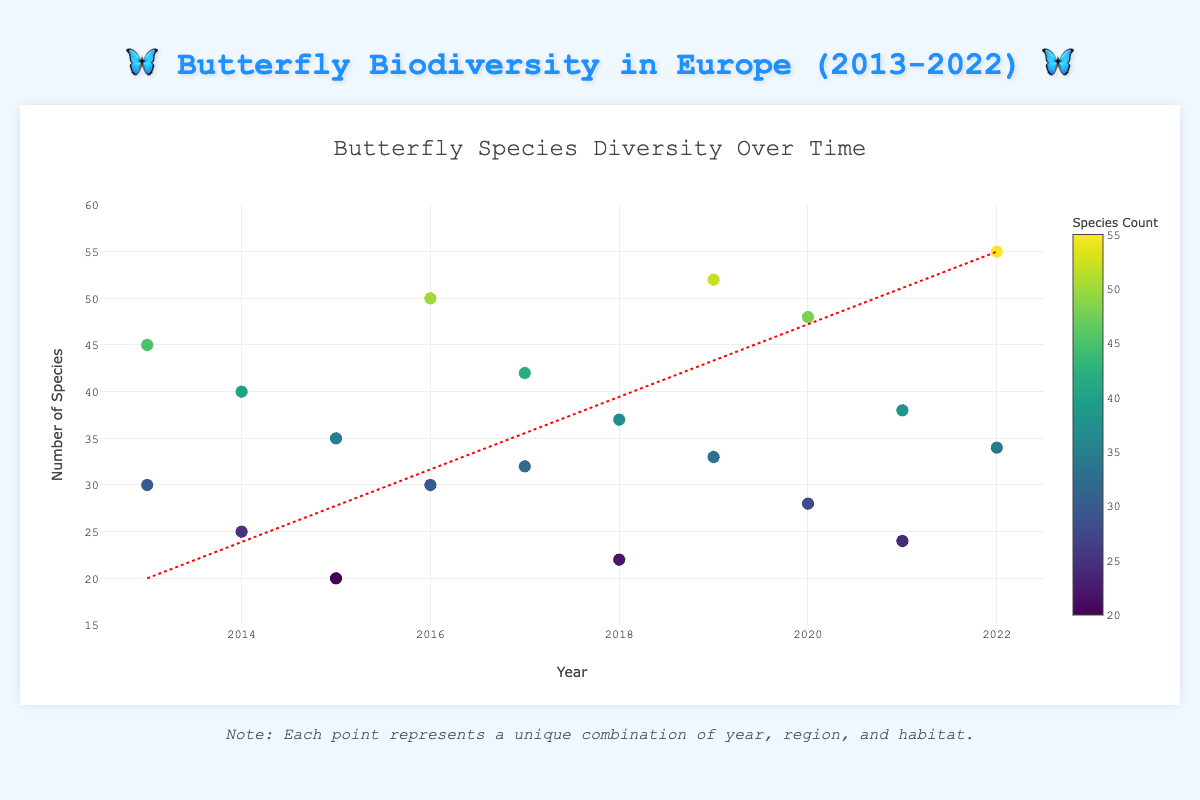what is the trend of butterfly species diversity over the years? The trend line in the scatter plot indicates a positive trend, showing that the number of butterfly species tends to increase over the years. This is visible from the line moving from the lower-left portion of the graph to the upper-right.
Answer: Increasing how many regions were studied in the dataset? By examining the number of unique regions in the scatter plot's hover information, one can count the mentions of different regions. The regions listed are: Mediterranean, Northern Europe, Western Europe, Eastern Europe, Southern Europe, and Central Europe.
Answer: 6 which habitat had the highest species count in a single year? By inspecting the hover information of the points and their corresponding species count, one can determine that the 'Coastal Areas' habitat in Southern Europe in 2022 had the highest species count of 55.
Answer: Coastal Areas what is the general range of butterfly species counted across all years? The y-axis shows the range of species count data points, extending from the lowest species count of 20 to the highest count of 55. These values are directly observable in the chart.
Answer: 20-55 which region had the greatest variation in species count over the years? By comparing the variation within each region's data points, one can see that the Mediterranean region had significant fluctuation, ranging from 30 in forests to 48 in grasslands. This can be confirmed by looking at the spread of data points associated with the Mediterranean region.
Answer: Mediterranean which years show data points for the 'Urban Gardens' habitat? By examining the scatter plot's hover information and noting the years associated with 'Urban Gardens' data points, one finds they appear in 2015, 2018, and 2021.
Answer: 2015, 2018, 2021 does Northern Europe show an increase or decrease in butterfly species in wetlands from 2014 to 2020? By comparing the hover information for wetlands in Northern Europe, species counts are 25 in 2014 and 28 in 2020, indicating a small increase.
Answer: Increase are there any outliers in the data? An outlier point is one that deviates markedly from other points. The 'Coastal Areas' habitat in Southern Europe in 2022, with a species count of 55, appears much higher than other points, suggesting it is an outlier.
Answer: Yes, Coastal Areas in Southern Europe in 2022 how does the species count in Central Europe in agrarian fields change between 2016 and 2022? Observing the points for Central Europe in agrarian fields, species counts are 30 in 2016 and 34 in 2022. This indicates an increase of 4 species over the period.
Answer: Increase which habitat types are represented in the Mediterranean region? By inspecting the hover information of data points associated with the Mediterranean region, the habitat types identified are 'Grassland' and 'Forest'.
Answer: Grassland, Forest 